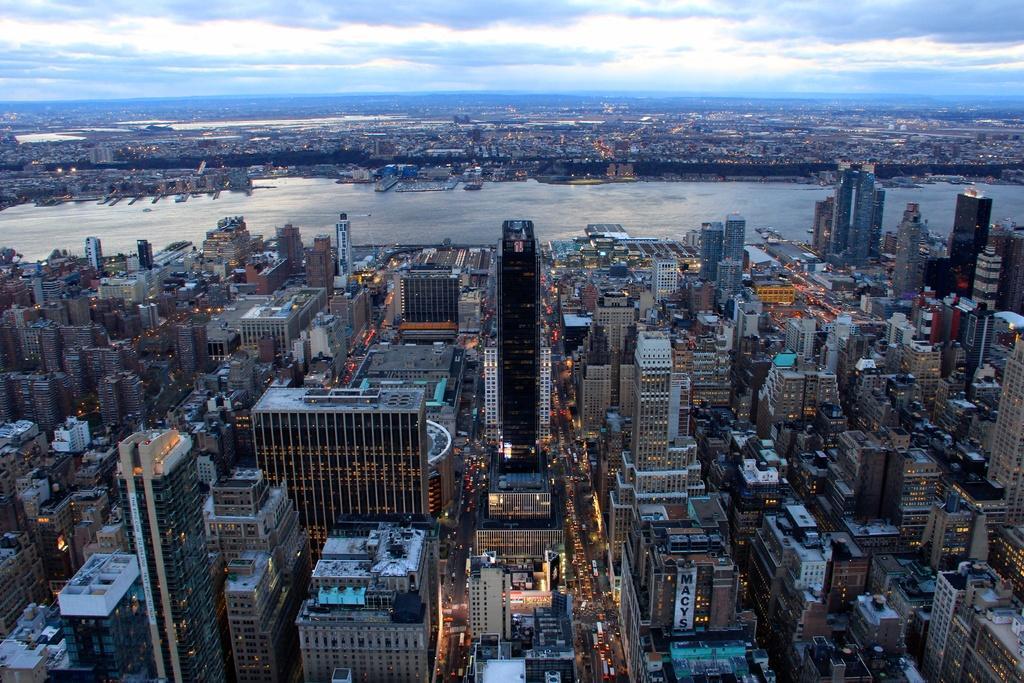How would you summarize this image in a sentence or two? In this image I can see the top view of a seaside city with the buildings, roads, vehicles on both sides of the sea, At the top of the image I can see the sky.  